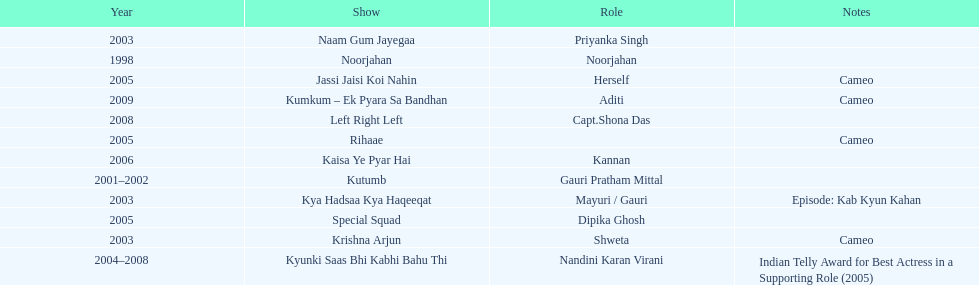What was the most years a show lasted? 4. 